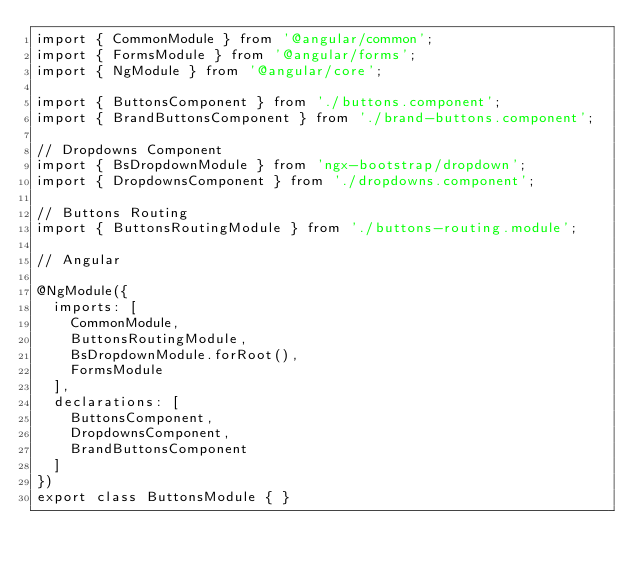<code> <loc_0><loc_0><loc_500><loc_500><_TypeScript_>import { CommonModule } from '@angular/common';
import { FormsModule } from '@angular/forms';
import { NgModule } from '@angular/core';

import { ButtonsComponent } from './buttons.component';
import { BrandButtonsComponent } from './brand-buttons.component';

// Dropdowns Component
import { BsDropdownModule } from 'ngx-bootstrap/dropdown';
import { DropdownsComponent } from './dropdowns.component';

// Buttons Routing
import { ButtonsRoutingModule } from './buttons-routing.module';

// Angular

@NgModule({
  imports: [
    CommonModule,
    ButtonsRoutingModule,
    BsDropdownModule.forRoot(),
    FormsModule
  ],
  declarations: [
    ButtonsComponent,
    DropdownsComponent,
    BrandButtonsComponent
  ]
})
export class ButtonsModule { }</code> 